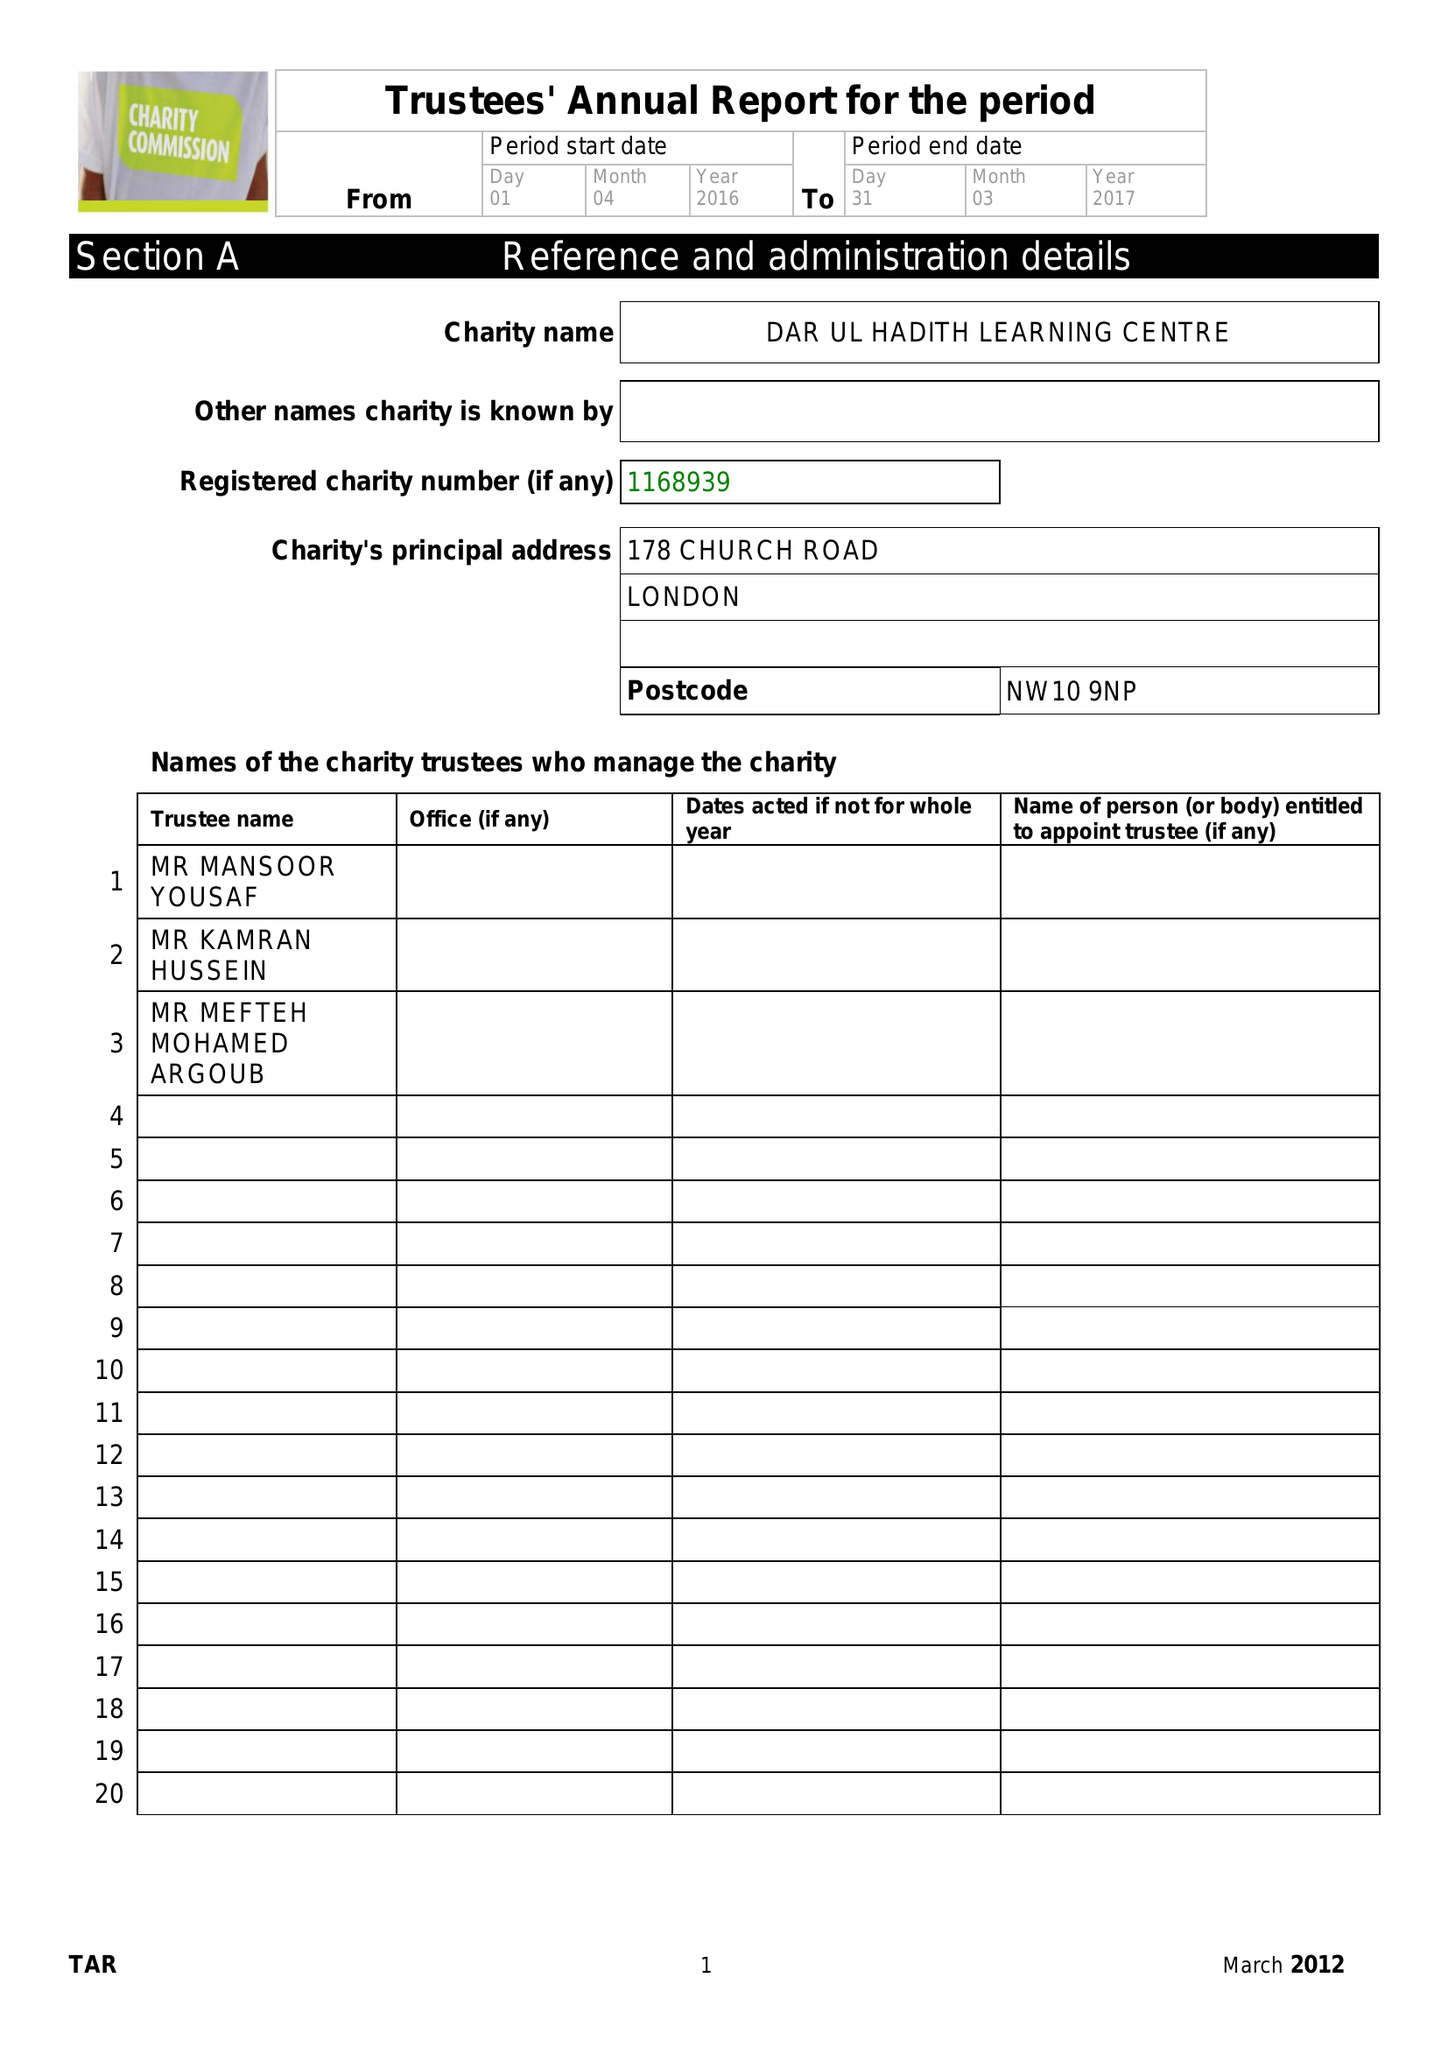What is the value for the spending_annually_in_british_pounds?
Answer the question using a single word or phrase. 12274.00 